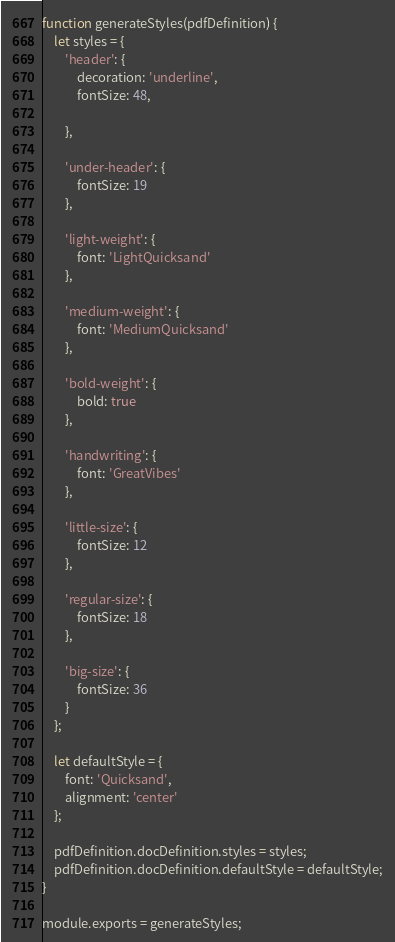Convert code to text. <code><loc_0><loc_0><loc_500><loc_500><_JavaScript_>function generateStyles(pdfDefinition) {
    let styles = {
        'header': {
            decoration: 'underline',
            fontSize: 48,

        },

        'under-header': {
            fontSize: 19
        },

        'light-weight': {
            font: 'LightQuicksand'
        },

        'medium-weight': {
            font: 'MediumQuicksand'
        },

        'bold-weight': {
            bold: true
        },

        'handwriting': {
            font: 'GreatVibes'
        },

        'little-size': {
            fontSize: 12
        },

        'regular-size': {
            fontSize: 18
        },

        'big-size': {
            fontSize: 36
        }
    };

    let defaultStyle = {
        font: 'Quicksand',
        alignment: 'center'
    };

    pdfDefinition.docDefinition.styles = styles;
    pdfDefinition.docDefinition.defaultStyle = defaultStyle;
}

module.exports = generateStyles;</code> 